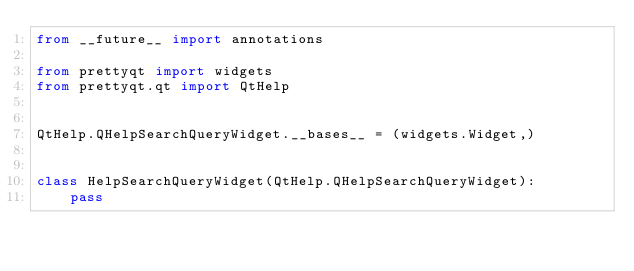<code> <loc_0><loc_0><loc_500><loc_500><_Python_>from __future__ import annotations

from prettyqt import widgets
from prettyqt.qt import QtHelp


QtHelp.QHelpSearchQueryWidget.__bases__ = (widgets.Widget,)


class HelpSearchQueryWidget(QtHelp.QHelpSearchQueryWidget):
    pass
</code> 